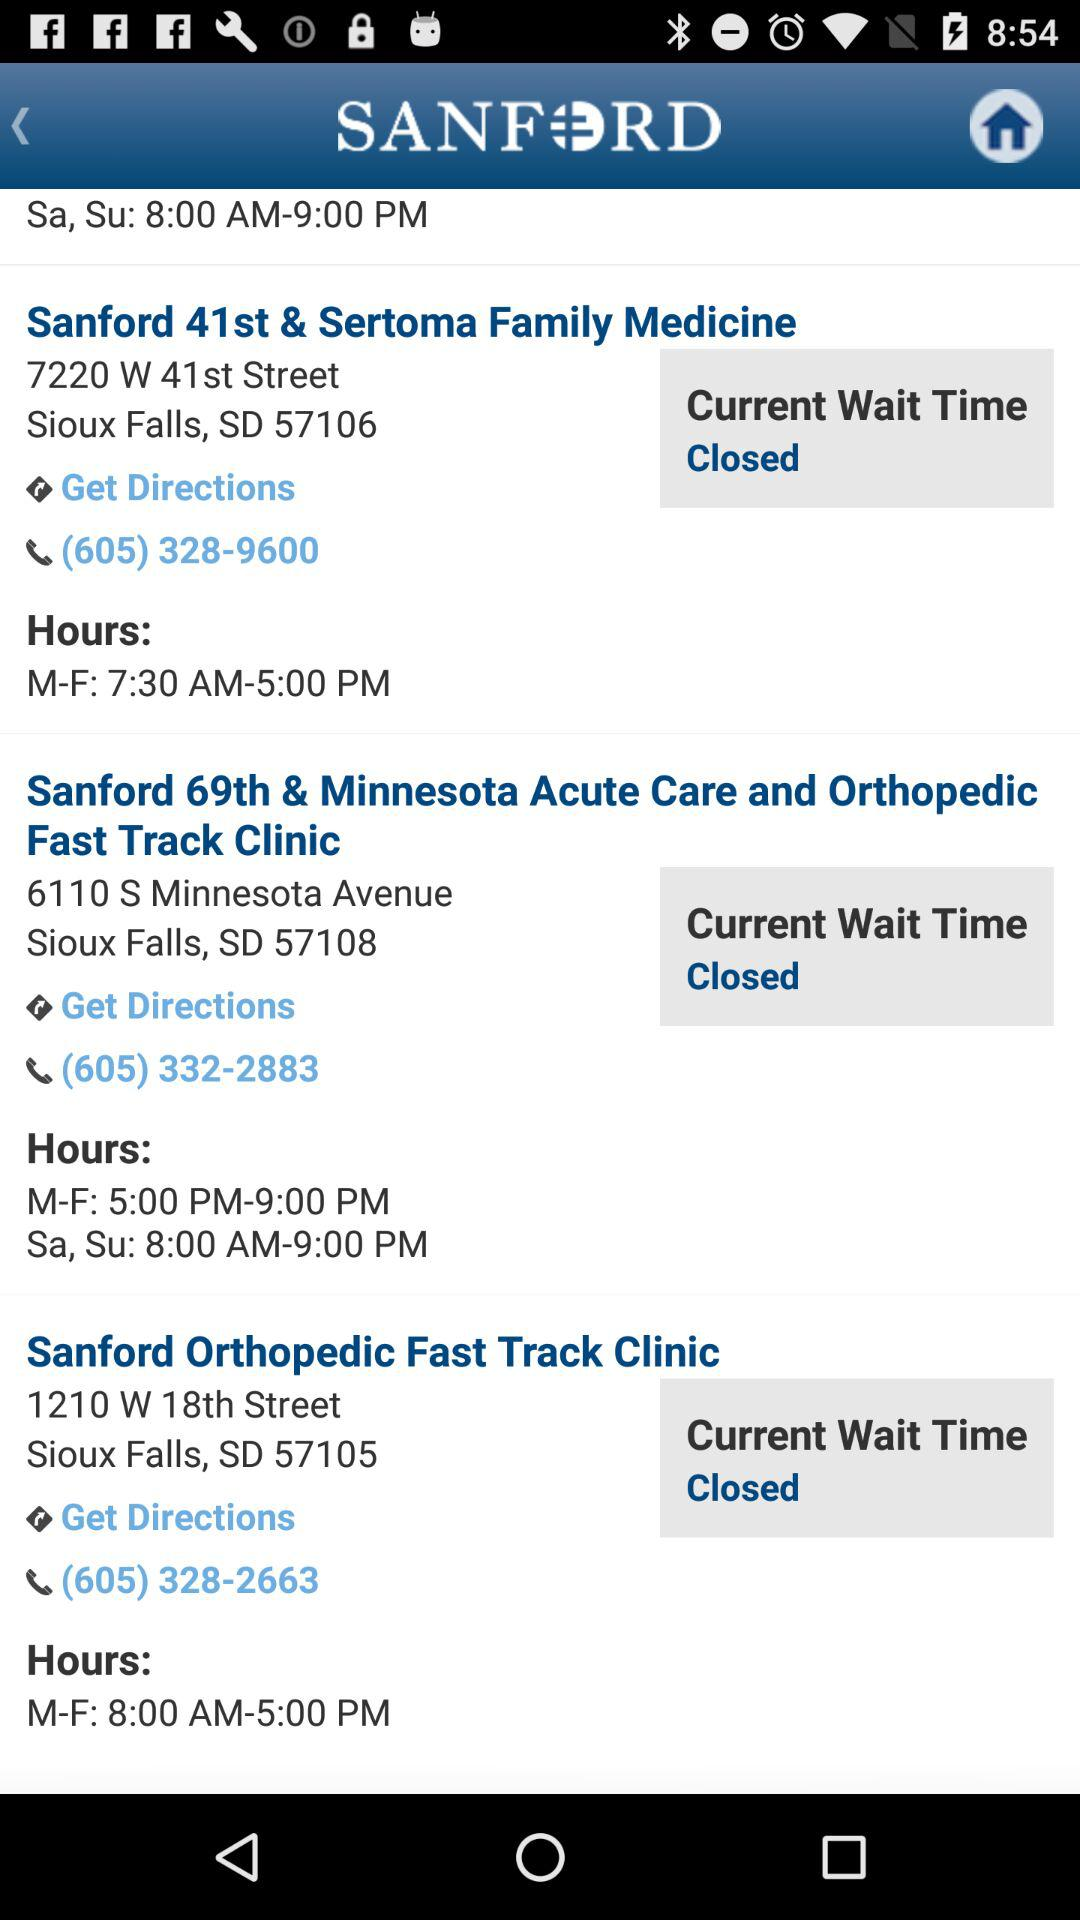Where is the Sanford Orthopedic Fast Track Clinic located? It is located at 1210 W. 18th Street, Sioux Falls, SD 57105. 